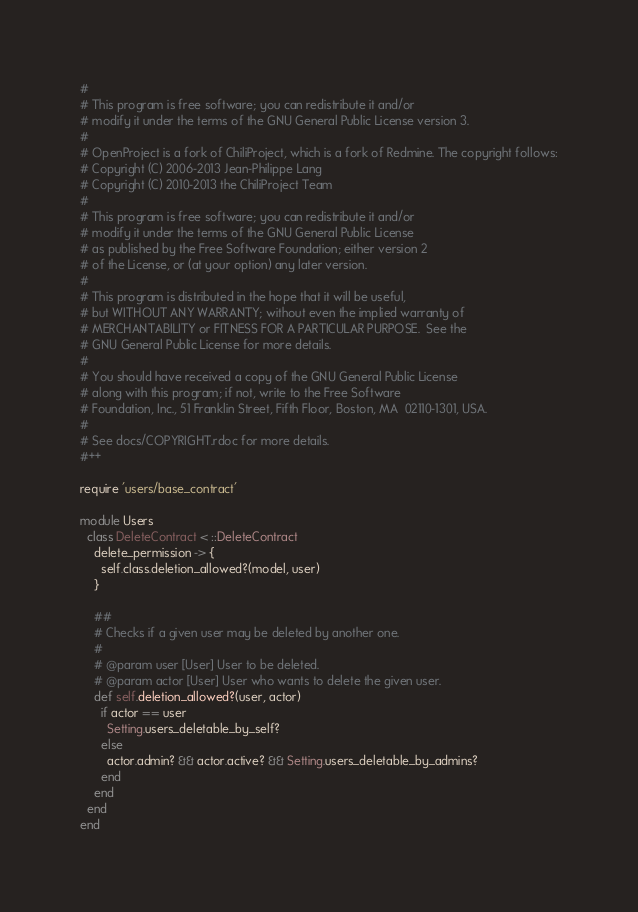Convert code to text. <code><loc_0><loc_0><loc_500><loc_500><_Ruby_>#
# This program is free software; you can redistribute it and/or
# modify it under the terms of the GNU General Public License version 3.
#
# OpenProject is a fork of ChiliProject, which is a fork of Redmine. The copyright follows:
# Copyright (C) 2006-2013 Jean-Philippe Lang
# Copyright (C) 2010-2013 the ChiliProject Team
#
# This program is free software; you can redistribute it and/or
# modify it under the terms of the GNU General Public License
# as published by the Free Software Foundation; either version 2
# of the License, or (at your option) any later version.
#
# This program is distributed in the hope that it will be useful,
# but WITHOUT ANY WARRANTY; without even the implied warranty of
# MERCHANTABILITY or FITNESS FOR A PARTICULAR PURPOSE.  See the
# GNU General Public License for more details.
#
# You should have received a copy of the GNU General Public License
# along with this program; if not, write to the Free Software
# Foundation, Inc., 51 Franklin Street, Fifth Floor, Boston, MA  02110-1301, USA.
#
# See docs/COPYRIGHT.rdoc for more details.
#++

require 'users/base_contract'

module Users
  class DeleteContract < ::DeleteContract
    delete_permission -> {
      self.class.deletion_allowed?(model, user)
    }

    ##
    # Checks if a given user may be deleted by another one.
    #
    # @param user [User] User to be deleted.
    # @param actor [User] User who wants to delete the given user.
    def self.deletion_allowed?(user, actor)
      if actor == user
        Setting.users_deletable_by_self?
      else
        actor.admin? && actor.active? && Setting.users_deletable_by_admins?
      end
    end
  end
end
</code> 